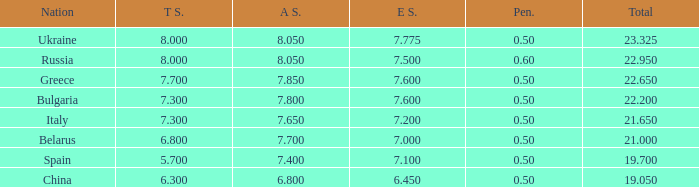What E score has the T score of 8 and a number smaller than 22.95? None. 